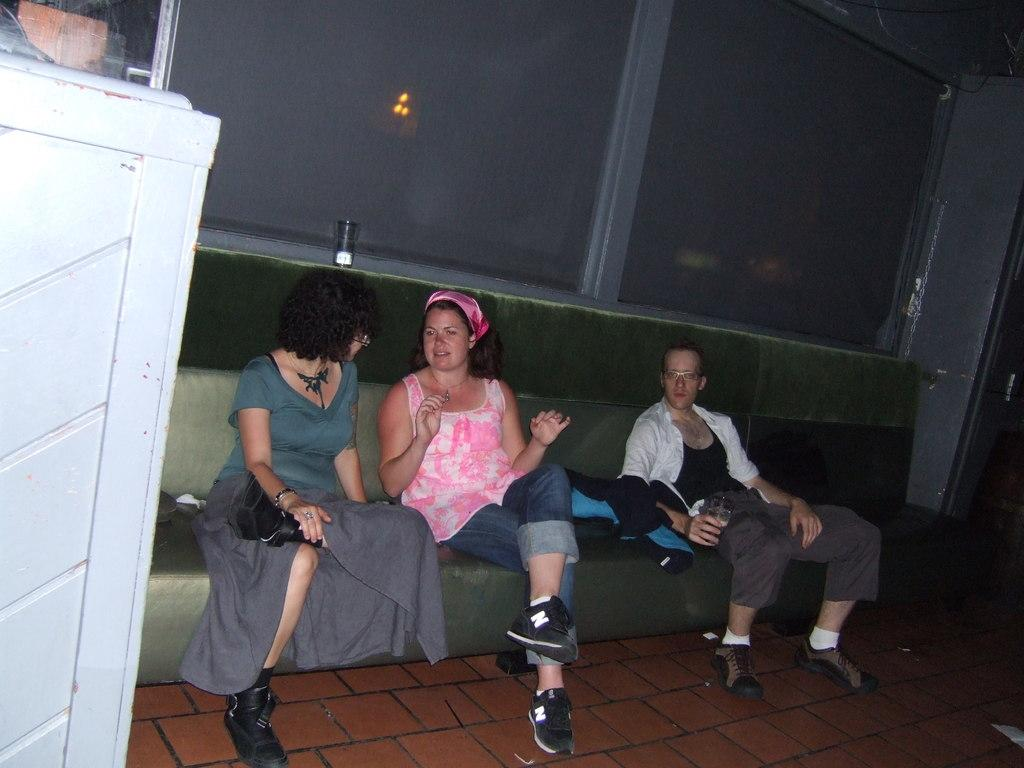How many people are sitting on the couch in the image? There are three persons sitting on a couch in the image. What can be seen on the left side of the image? There is a white object on the left side of the image. What is visible through the window in the image? There is an object visible in the window. What question is being asked on the page in the image? There is no page or question present in the image. 